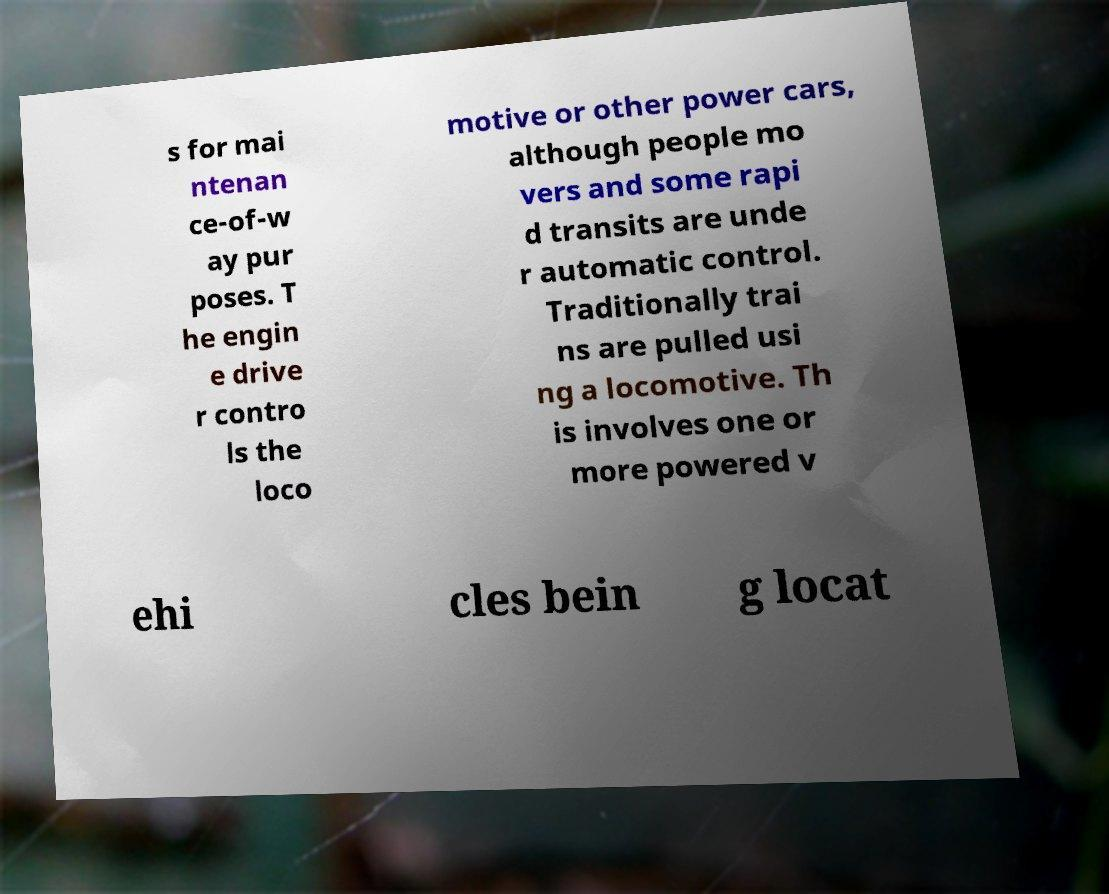For documentation purposes, I need the text within this image transcribed. Could you provide that? s for mai ntenan ce-of-w ay pur poses. T he engin e drive r contro ls the loco motive or other power cars, although people mo vers and some rapi d transits are unde r automatic control. Traditionally trai ns are pulled usi ng a locomotive. Th is involves one or more powered v ehi cles bein g locat 